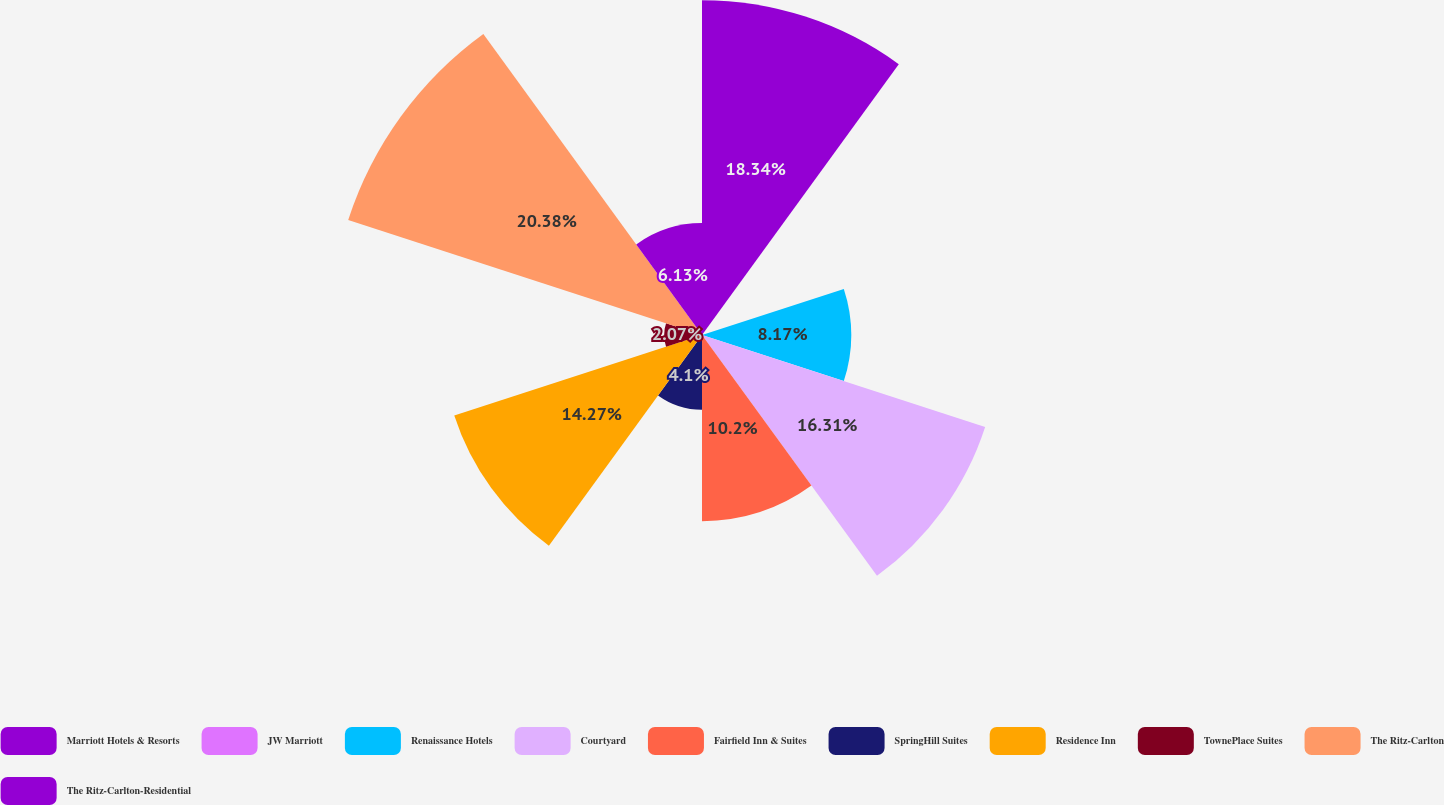<chart> <loc_0><loc_0><loc_500><loc_500><pie_chart><fcel>Marriott Hotels & Resorts<fcel>JW Marriott<fcel>Renaissance Hotels<fcel>Courtyard<fcel>Fairfield Inn & Suites<fcel>SpringHill Suites<fcel>Residence Inn<fcel>TownePlace Suites<fcel>The Ritz-Carlton<fcel>The Ritz-Carlton-Residential<nl><fcel>18.34%<fcel>0.03%<fcel>8.17%<fcel>16.31%<fcel>10.2%<fcel>4.1%<fcel>14.27%<fcel>2.07%<fcel>20.38%<fcel>6.13%<nl></chart> 